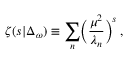<formula> <loc_0><loc_0><loc_500><loc_500>\zeta ( s | \Delta _ { \omega } ) \equiv \sum _ { n } \left ( { \frac { \mu ^ { 2 } } { \lambda _ { n } } } \right ) ^ { s } \, ,</formula> 